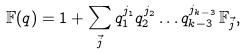<formula> <loc_0><loc_0><loc_500><loc_500>\mathbb { F } ( q ) = 1 + \sum _ { \vec { j } } q _ { 1 } ^ { j _ { 1 } } q _ { 2 } ^ { j _ { 2 } } \dots q _ { k - 3 } ^ { j _ { k - 3 } } \, \mathbb { F } _ { \vec { j } } ,</formula> 